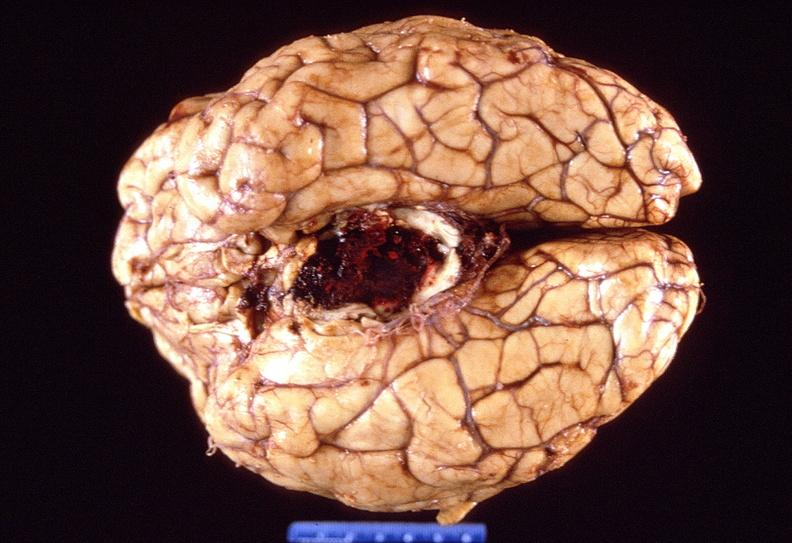s nervous present?
Answer the question using a single word or phrase. Yes 